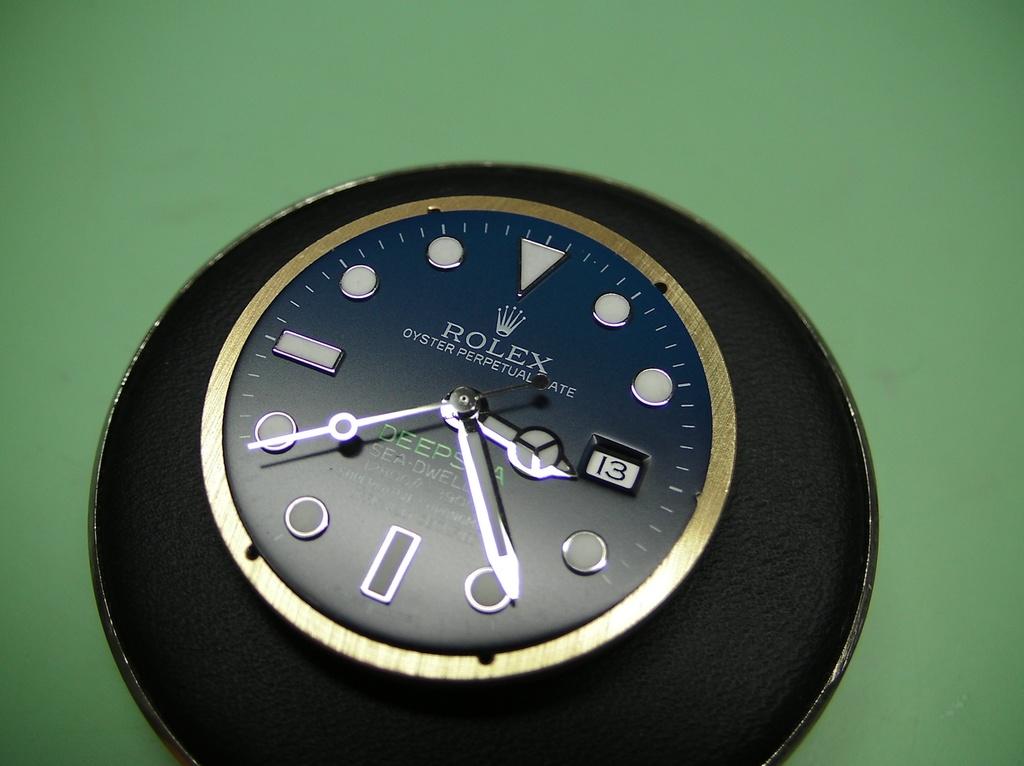What time is indicated by the clock?
Ensure brevity in your answer.  3:24. What type of watch is this?
Your response must be concise. Rolex. 